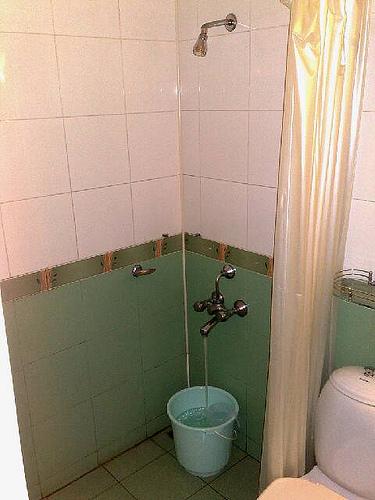Is the light on in the bathroom?
Write a very short answer. Yes. Is the faucet working as intended?
Answer briefly. Yes. Is the bathroom new?
Be succinct. No. Is this a normal faucet?
Be succinct. No. What color are the bottom tiles?
Keep it brief. Green. 